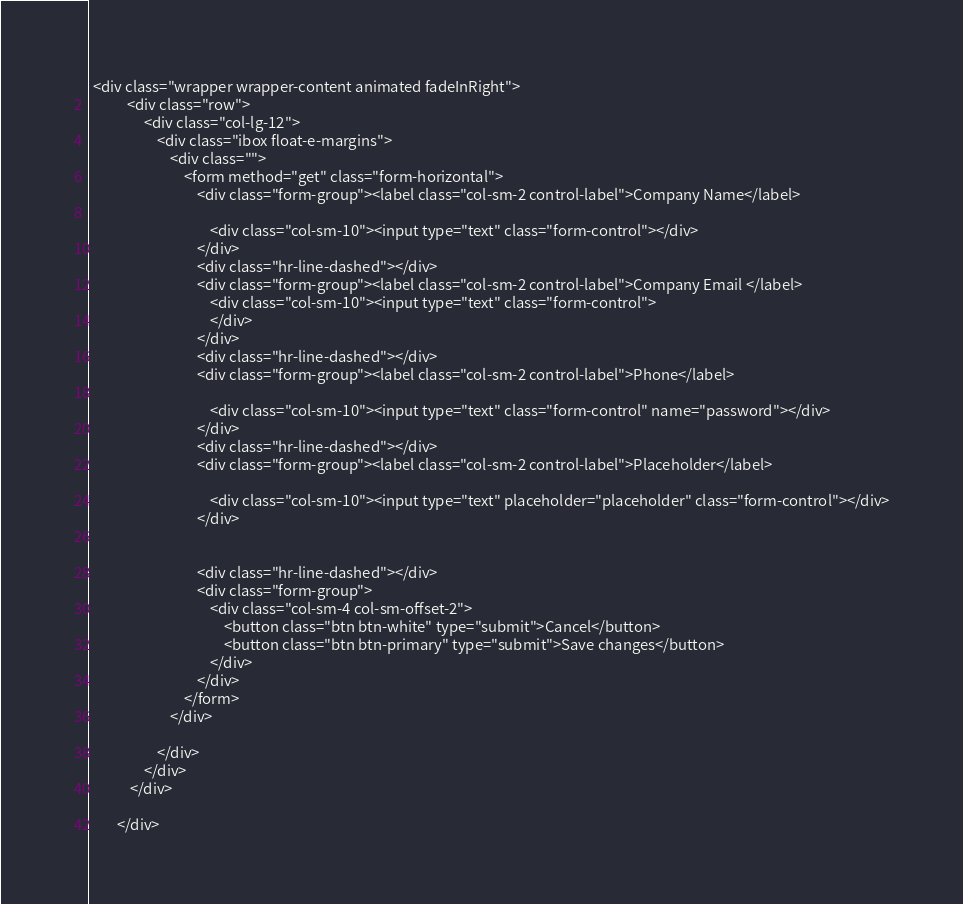Convert code to text. <code><loc_0><loc_0><loc_500><loc_500><_PHP_> <div class="wrapper wrapper-content animated fadeInRight">
           <div class="row">
                <div class="col-lg-12">
                    <div class="ibox float-e-margins">
                        <div class="">
                            <form method="get" class="form-horizontal">
                                <div class="form-group"><label class="col-sm-2 control-label">Company Name</label>

                                    <div class="col-sm-10"><input type="text" class="form-control"></div>
                                </div>
                                <div class="hr-line-dashed"></div>
                                <div class="form-group"><label class="col-sm-2 control-label">Company Email </label>
                                    <div class="col-sm-10"><input type="text" class="form-control"> 
                                    </div>
                                </div>
                                <div class="hr-line-dashed"></div>
                                <div class="form-group"><label class="col-sm-2 control-label">Phone</label>

                                    <div class="col-sm-10"><input type="text" class="form-control" name="password"></div>
                                </div>
                                <div class="hr-line-dashed"></div>
                                <div class="form-group"><label class="col-sm-2 control-label">Placeholder</label>

                                    <div class="col-sm-10"><input type="text" placeholder="placeholder" class="form-control"></div>
                                </div>
                                

                                <div class="hr-line-dashed"></div>
                                <div class="form-group">
                                    <div class="col-sm-4 col-sm-offset-2">
                                        <button class="btn btn-white" type="submit">Cancel</button>
                                        <button class="btn btn-primary" type="submit">Save changes</button>
                                    </div>
                                </div>
                            </form>
                        </div>
                       
                    </div>
                </div>
            </div>
           
        </div></code> 